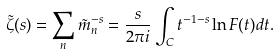Convert formula to latex. <formula><loc_0><loc_0><loc_500><loc_500>\tilde { \zeta } ( s ) = \sum _ { n } \tilde { m } _ { n } ^ { - s } = \frac { s } { 2 \pi i } \int _ { C } t ^ { - 1 - s } \ln F ( t ) d t .</formula> 